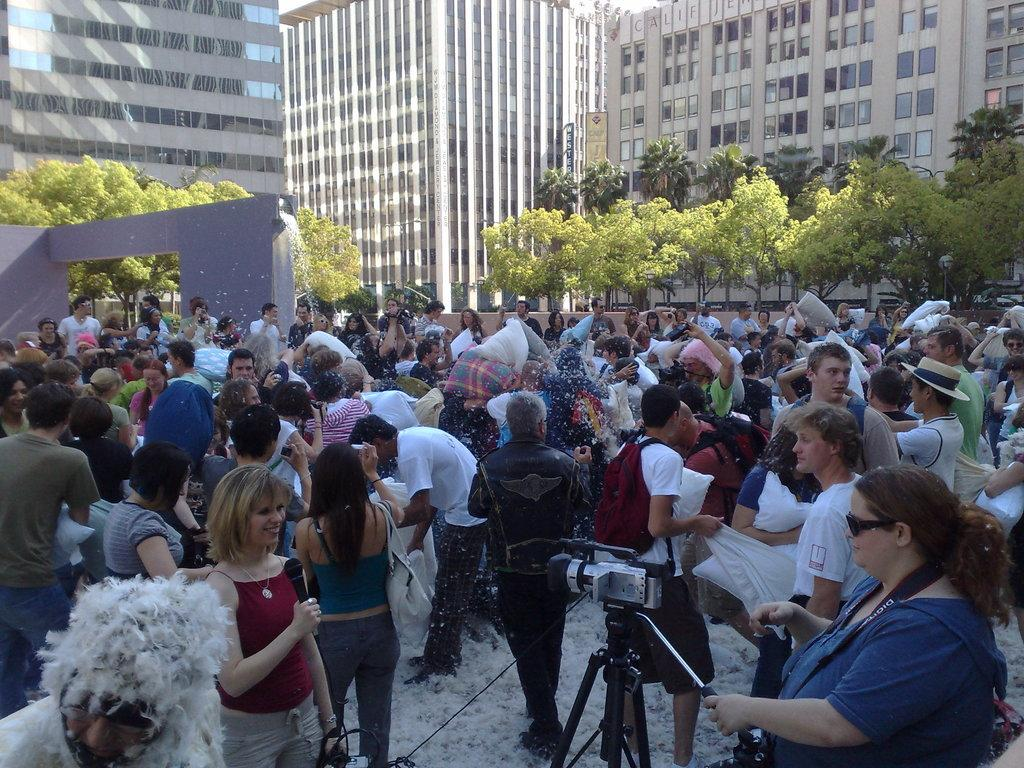What is happening in the image involving the persons on the ground? There are many persons on the ground in the image, but their specific activity is not clear. What object is visible in the image that is used for capturing images? There is a camera visible in the image. What type of natural elements can be seen in the image? There are trees in the image. What type of man-made structures can be seen in the image? There are buildings in the image. What type of barrier is present in the image? There is a wall in the image. What type of trousers are the trees wearing in the image? Trees do not wear trousers, as they are natural elements and not human beings. How can the camera be used to measure the distance between the buildings in the image? The camera is not used for measuring distances; it is used for capturing images. 